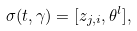<formula> <loc_0><loc_0><loc_500><loc_500>\sigma ( t , \gamma ) = [ z _ { j , i } , \theta ^ { l } ] ,</formula> 